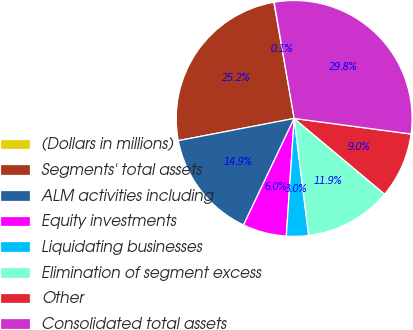<chart> <loc_0><loc_0><loc_500><loc_500><pie_chart><fcel>(Dollars in millions)<fcel>Segments' total assets<fcel>ALM activities including<fcel>Equity investments<fcel>Liquidating businesses<fcel>Elimination of segment excess<fcel>Other<fcel>Consolidated total assets<nl><fcel>0.05%<fcel>25.25%<fcel>14.93%<fcel>6.0%<fcel>3.02%<fcel>11.95%<fcel>8.98%<fcel>29.82%<nl></chart> 